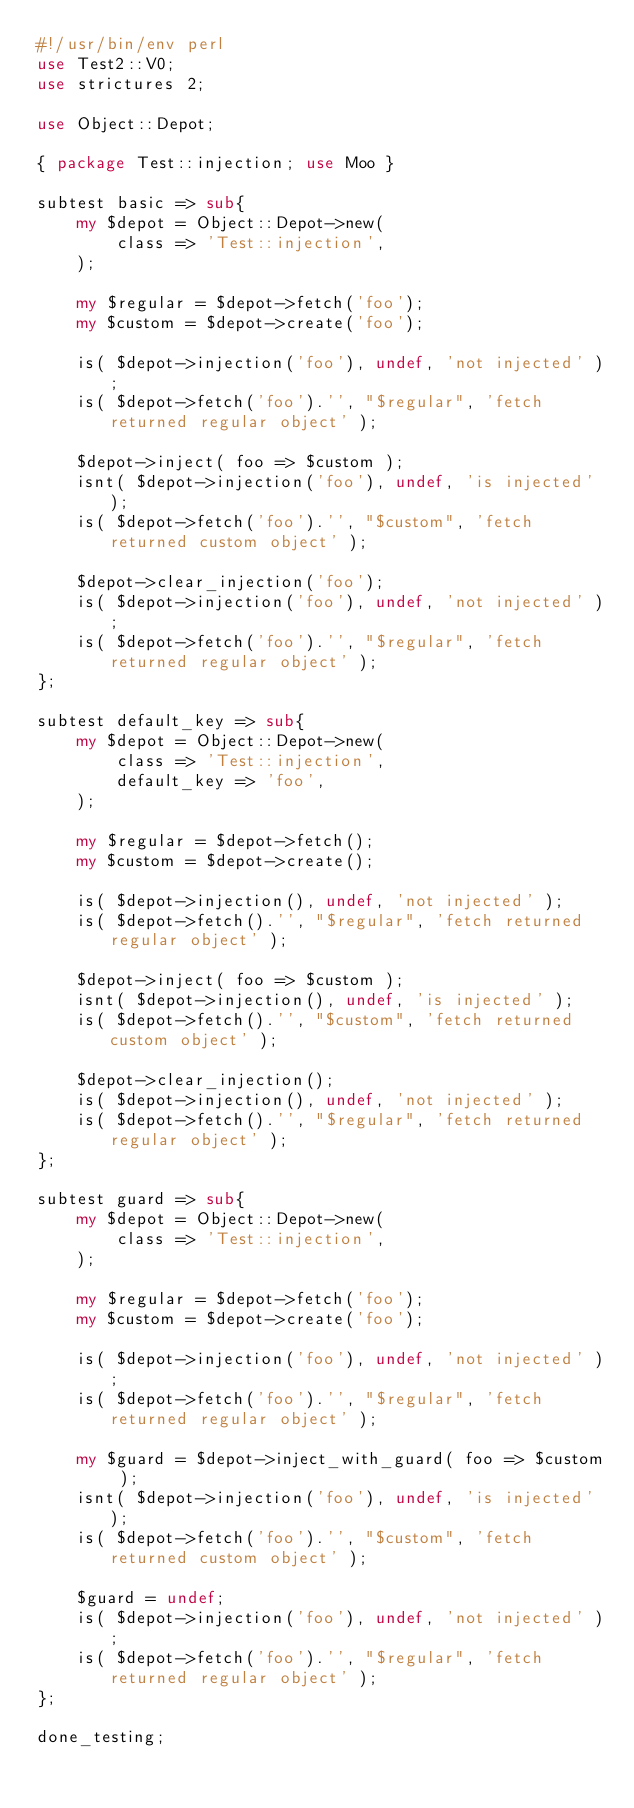<code> <loc_0><loc_0><loc_500><loc_500><_Perl_>#!/usr/bin/env perl
use Test2::V0;
use strictures 2;

use Object::Depot;

{ package Test::injection; use Moo }

subtest basic => sub{
    my $depot = Object::Depot->new(
        class => 'Test::injection',
    );

    my $regular = $depot->fetch('foo');
    my $custom = $depot->create('foo');

    is( $depot->injection('foo'), undef, 'not injected' );
    is( $depot->fetch('foo').'', "$regular", 'fetch returned regular object' );

    $depot->inject( foo => $custom );
    isnt( $depot->injection('foo'), undef, 'is injected' );
    is( $depot->fetch('foo').'', "$custom", 'fetch returned custom object' );

    $depot->clear_injection('foo');
    is( $depot->injection('foo'), undef, 'not injected' );
    is( $depot->fetch('foo').'', "$regular", 'fetch returned regular object' );
};

subtest default_key => sub{
    my $depot = Object::Depot->new(
        class => 'Test::injection',
        default_key => 'foo',
    );

    my $regular = $depot->fetch();
    my $custom = $depot->create();

    is( $depot->injection(), undef, 'not injected' );
    is( $depot->fetch().'', "$regular", 'fetch returned regular object' );

    $depot->inject( foo => $custom );
    isnt( $depot->injection(), undef, 'is injected' );
    is( $depot->fetch().'', "$custom", 'fetch returned custom object' );

    $depot->clear_injection();
    is( $depot->injection(), undef, 'not injected' );
    is( $depot->fetch().'', "$regular", 'fetch returned regular object' );
};

subtest guard => sub{
    my $depot = Object::Depot->new(
        class => 'Test::injection',
    );

    my $regular = $depot->fetch('foo');
    my $custom = $depot->create('foo');

    is( $depot->injection('foo'), undef, 'not injected' );
    is( $depot->fetch('foo').'', "$regular", 'fetch returned regular object' );

    my $guard = $depot->inject_with_guard( foo => $custom );
    isnt( $depot->injection('foo'), undef, 'is injected' );
    is( $depot->fetch('foo').'', "$custom", 'fetch returned custom object' );

    $guard = undef;
    is( $depot->injection('foo'), undef, 'not injected' );
    is( $depot->fetch('foo').'', "$regular", 'fetch returned regular object' );
};

done_testing;
</code> 